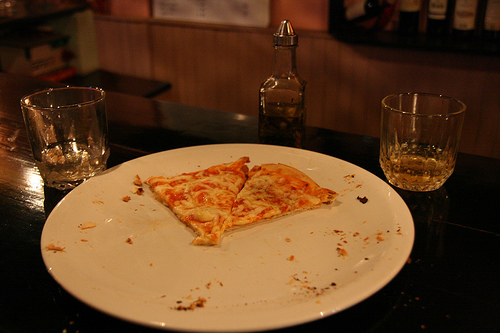Are there both pizzas and plates in this photo? Yes, the photo distinctly features slices of pizza along with a plate on which they are being served. 